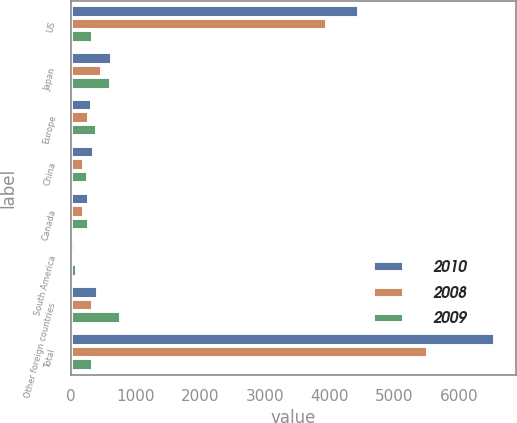<chart> <loc_0><loc_0><loc_500><loc_500><stacked_bar_chart><ecel><fcel>US<fcel>Japan<fcel>Europe<fcel>China<fcel>Canada<fcel>South America<fcel>Other foreign countries<fcel>Total<nl><fcel>2010<fcel>4464<fcel>631<fcel>334<fcel>356<fcel>276<fcel>70<fcel>421<fcel>6552<nl><fcel>2008<fcel>3961<fcel>485<fcel>277<fcel>209<fcel>209<fcel>49<fcel>338<fcel>5528<nl><fcel>2009<fcel>347<fcel>619<fcel>408<fcel>268<fcel>288<fcel>102<fcel>784<fcel>347<nl></chart> 